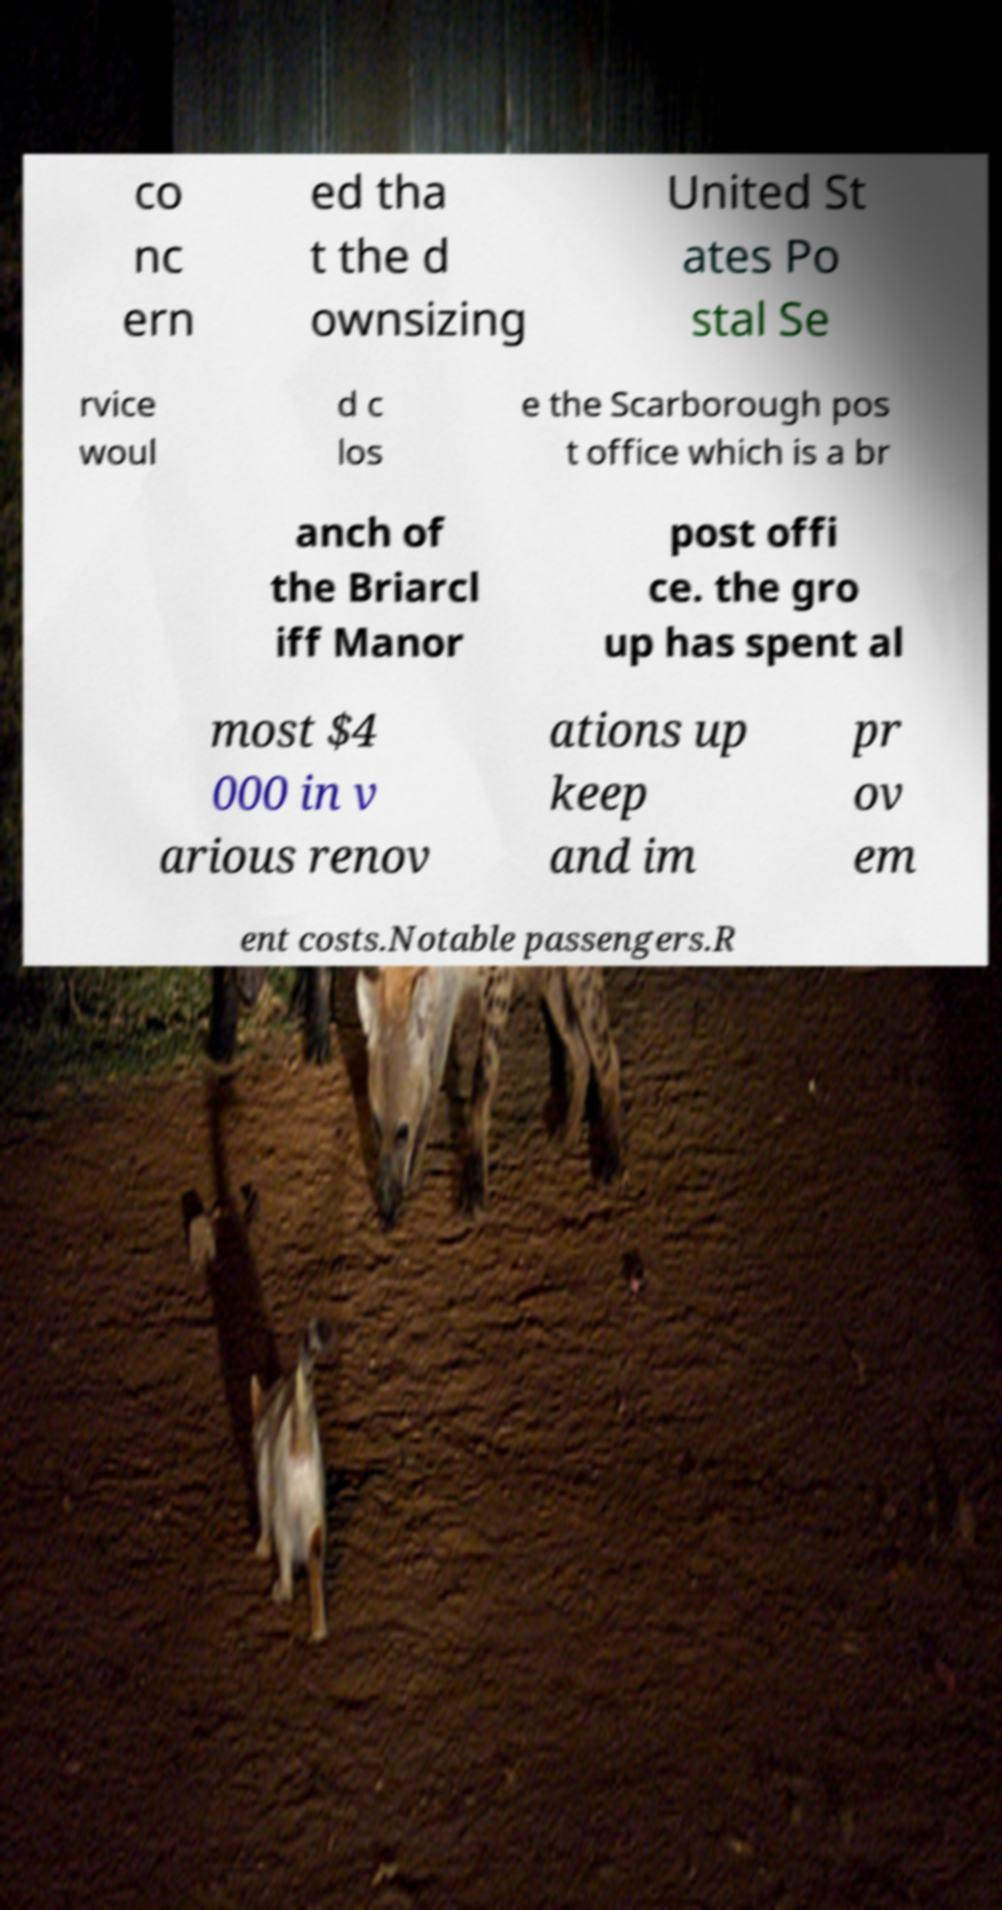Please read and relay the text visible in this image. What does it say? co nc ern ed tha t the d ownsizing United St ates Po stal Se rvice woul d c los e the Scarborough pos t office which is a br anch of the Briarcl iff Manor post offi ce. the gro up has spent al most $4 000 in v arious renov ations up keep and im pr ov em ent costs.Notable passengers.R 